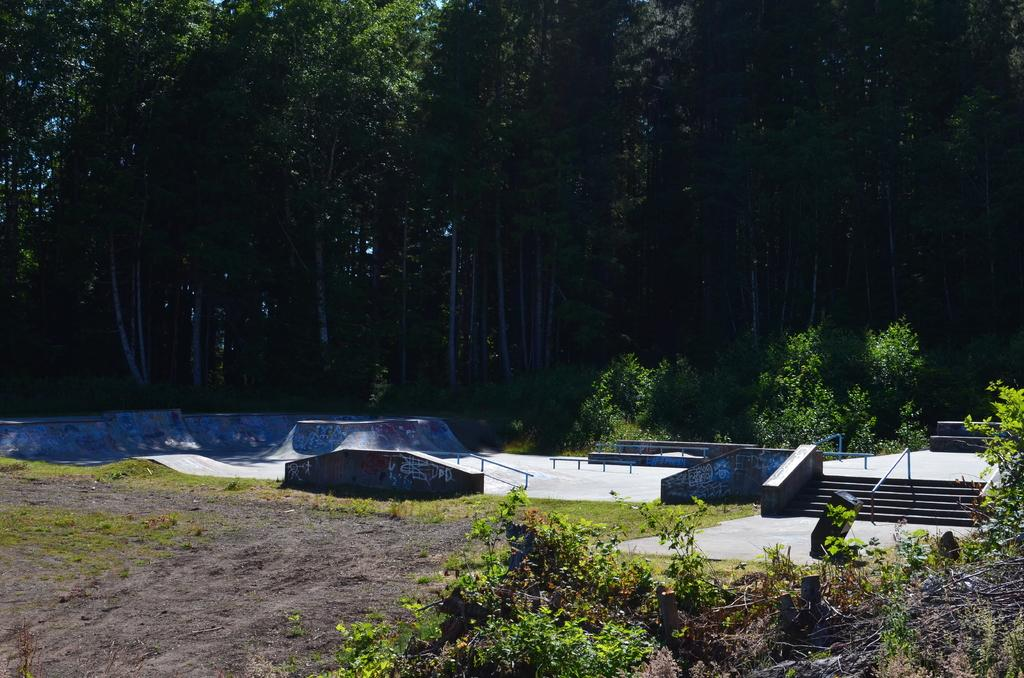What type of vegetation is located in the right corner of the image? There are plants in the right corner of the image. What can be seen in the background of the image? There are trees in the background of the image. Where is the minister standing in the image? There is no minister present in the image. Can you tell me how many rivers are visible in the image? There are no rivers visible in the image. 